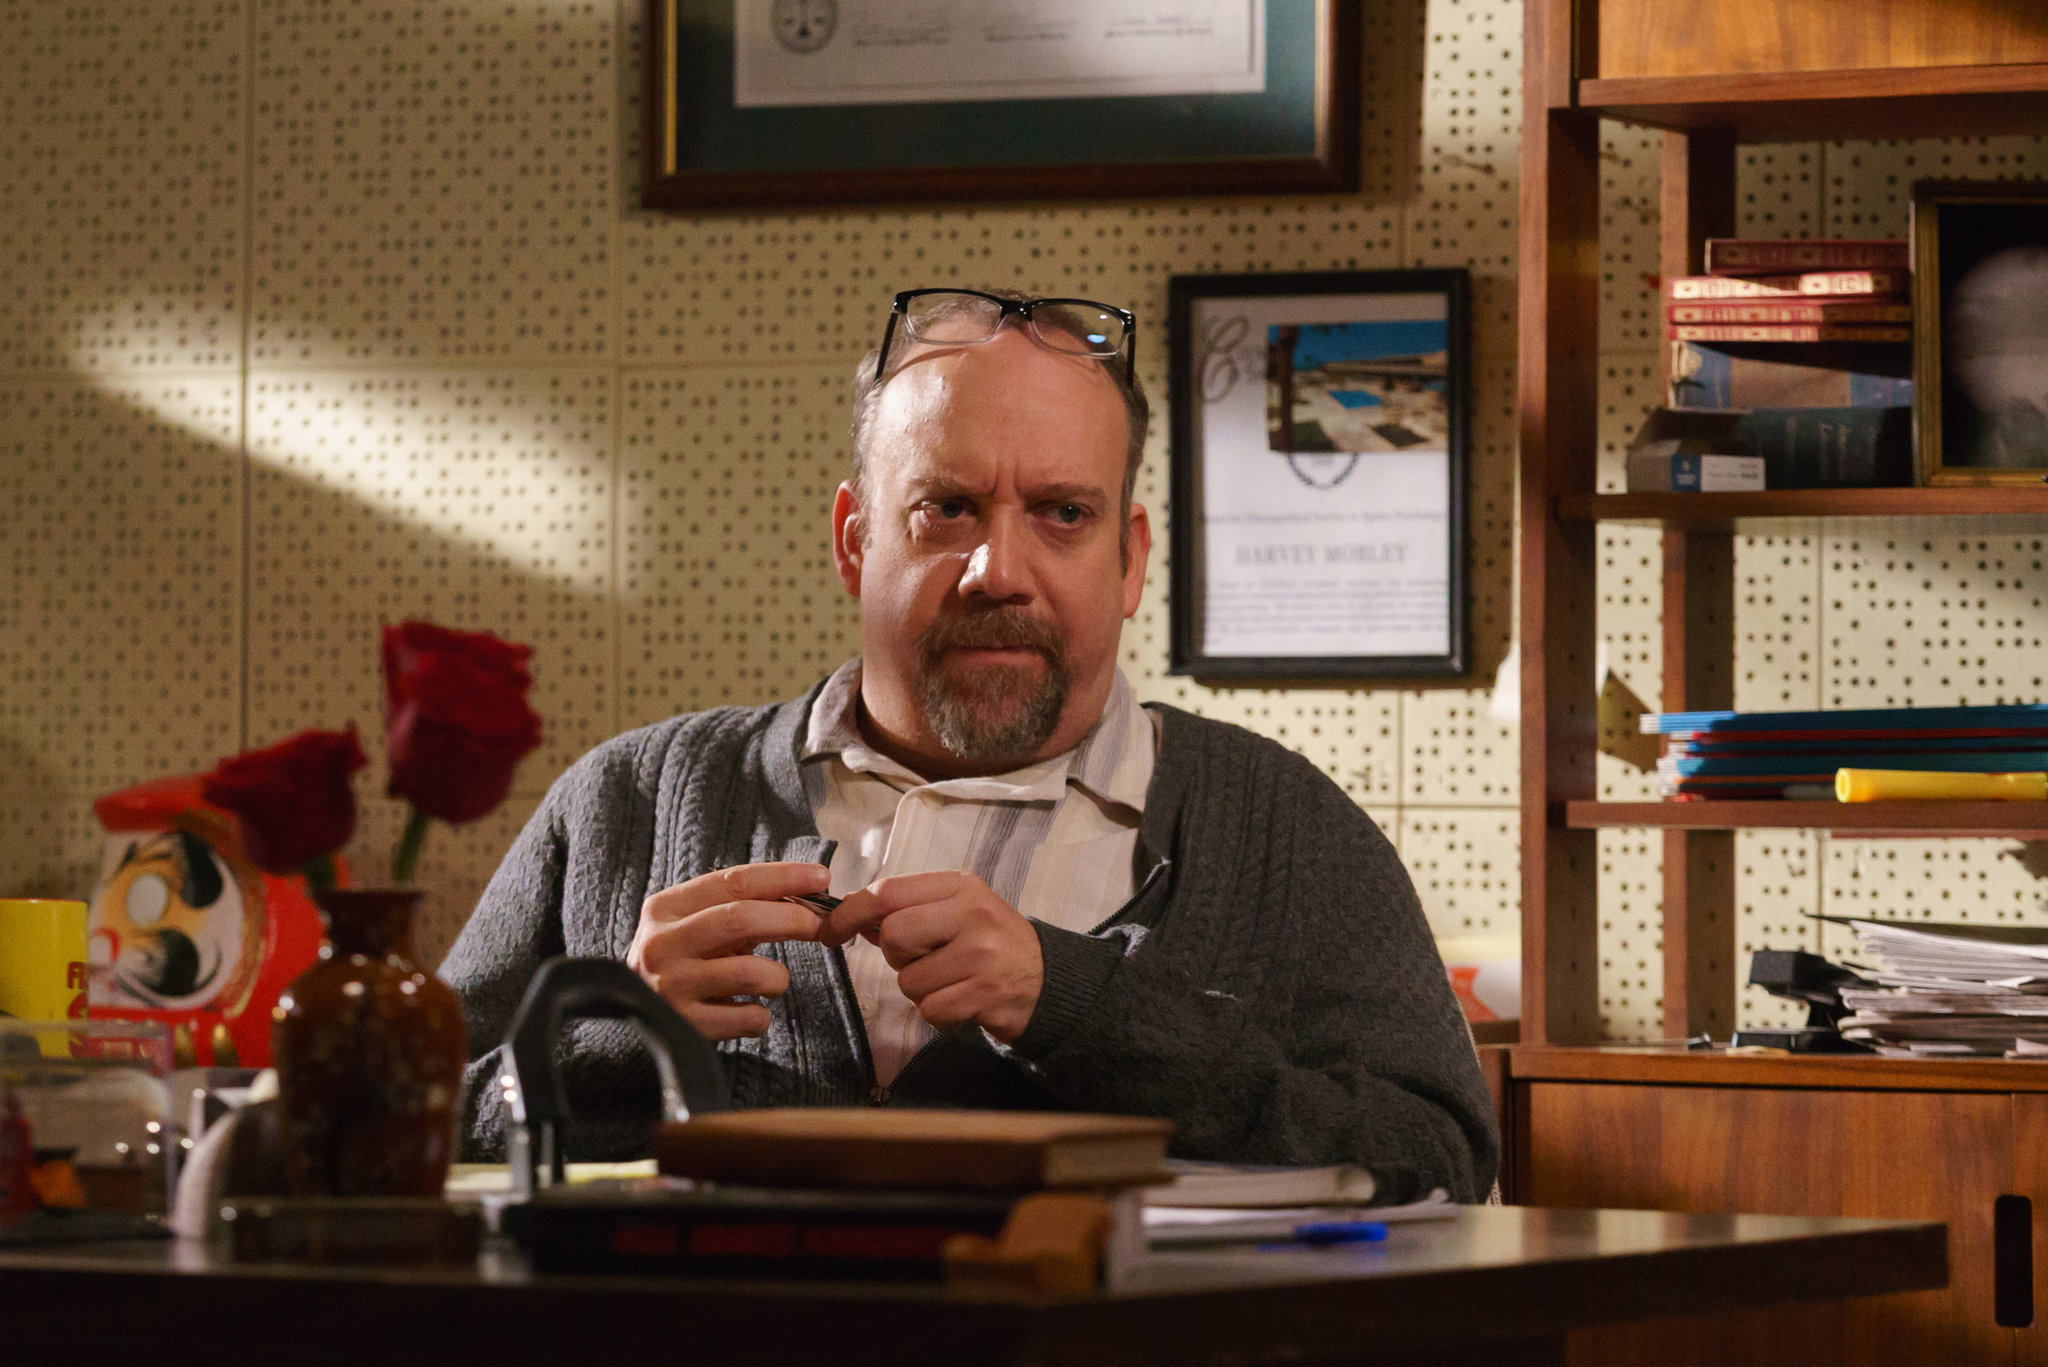Write a detailed description of the given image. In this image, we see a man who appears deeply engrossed in thought while seated at a desk within a somewhat cluttered office. The desk is scattered with books, papers, and a coffee mug, evoking a sense of a busy work environment. The man, dressed in a gray cardigan over a white collared shirt, holds a pen in his right hand, suggesting he might have been writing or reviewing documents. His glasses rest atop his head, hinting at a brief pause from reading. The expression on his face is serious and contemplative as he looks directly at the camera, highlighting his deep concentration.

The backdrop includes a bookshelf filled with books and various items, along with framed certificates and pictures on the wall, contributing to the scholarly atmosphere of the scene. The warm hues of brown and orange dominate the image, enhancing the intense, focused ambiance of the workspace. Adding to the personal touch of the setting, there is a vase with red roses and some colorful, decorative objects on the desk, indicating a blend of personal and professional life interwoven in this snapshot. 